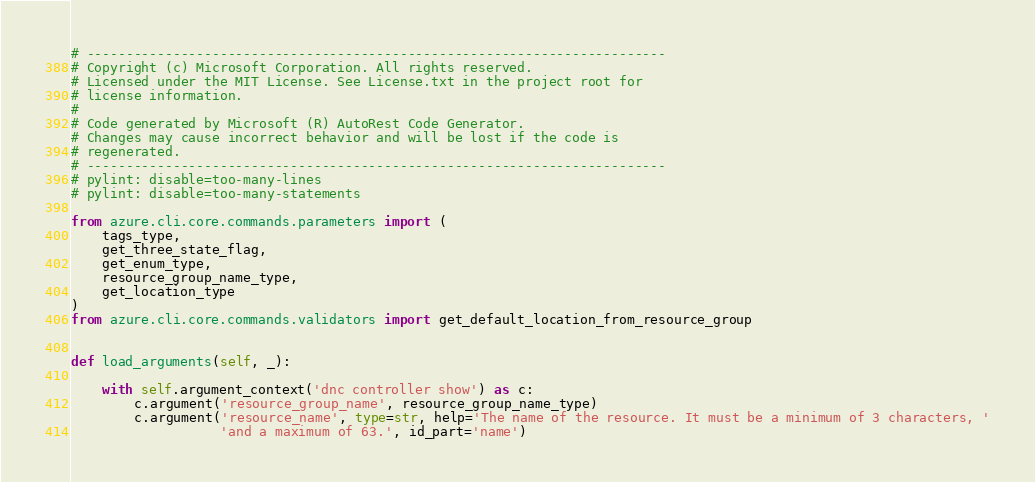<code> <loc_0><loc_0><loc_500><loc_500><_Python_># --------------------------------------------------------------------------
# Copyright (c) Microsoft Corporation. All rights reserved.
# Licensed under the MIT License. See License.txt in the project root for
# license information.
#
# Code generated by Microsoft (R) AutoRest Code Generator.
# Changes may cause incorrect behavior and will be lost if the code is
# regenerated.
# --------------------------------------------------------------------------
# pylint: disable=too-many-lines
# pylint: disable=too-many-statements

from azure.cli.core.commands.parameters import (
    tags_type,
    get_three_state_flag,
    get_enum_type,
    resource_group_name_type,
    get_location_type
)
from azure.cli.core.commands.validators import get_default_location_from_resource_group


def load_arguments(self, _):

    with self.argument_context('dnc controller show') as c:
        c.argument('resource_group_name', resource_group_name_type)
        c.argument('resource_name', type=str, help='The name of the resource. It must be a minimum of 3 characters, '
                   'and a maximum of 63.', id_part='name')
</code> 